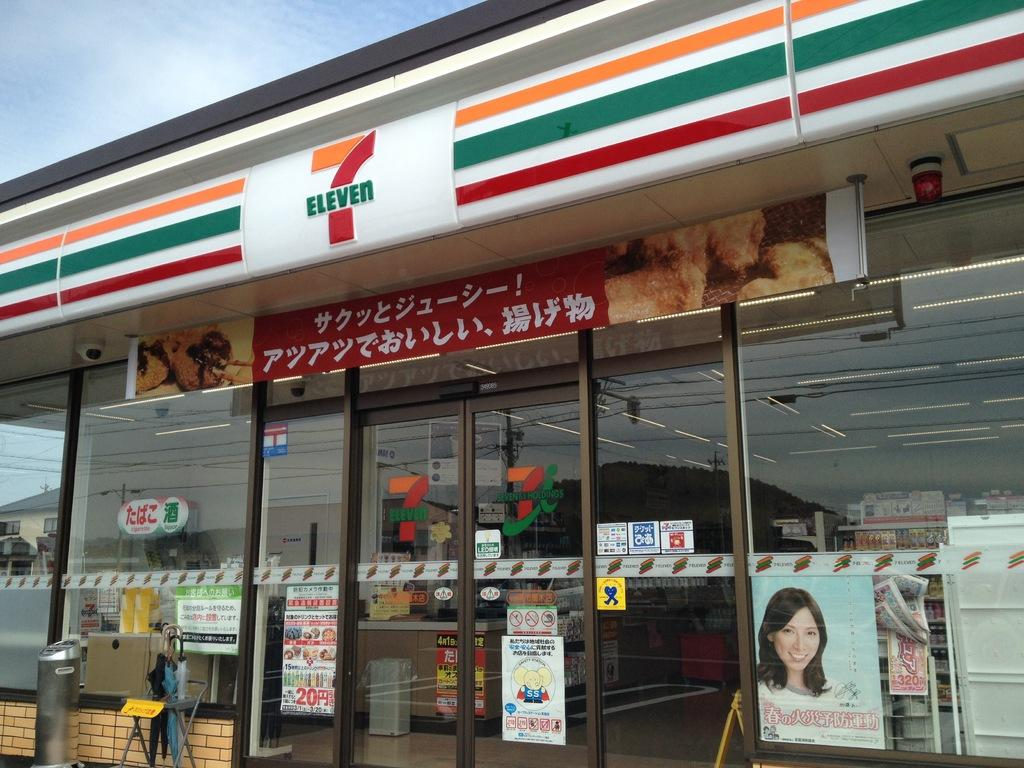<image>
Relay a brief, clear account of the picture shown. A 7 Eleven store in Japan has banners advertising their products on the windows. 